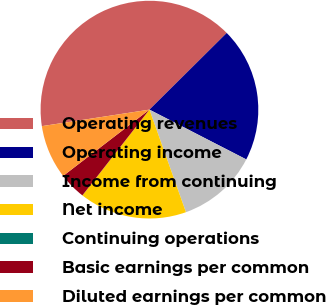Convert chart to OTSL. <chart><loc_0><loc_0><loc_500><loc_500><pie_chart><fcel>Operating revenues<fcel>Operating income<fcel>Income from continuing<fcel>Net income<fcel>Continuing operations<fcel>Basic earnings per common<fcel>Diluted earnings per common<nl><fcel>39.99%<fcel>20.0%<fcel>12.0%<fcel>16.0%<fcel>0.01%<fcel>4.01%<fcel>8.0%<nl></chart> 